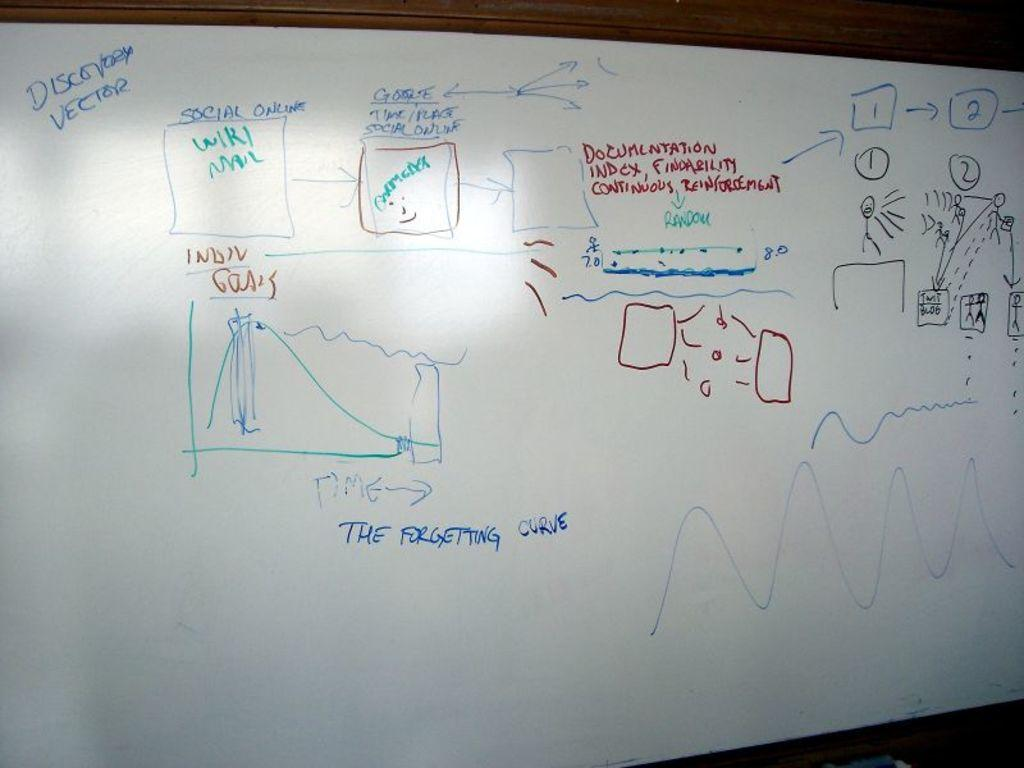<image>
Describe the image concisely. Discovery Vector wrote on a white board with the forgetting curve. 